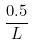Convert formula to latex. <formula><loc_0><loc_0><loc_500><loc_500>\frac { 0 . 5 } { L }</formula> 